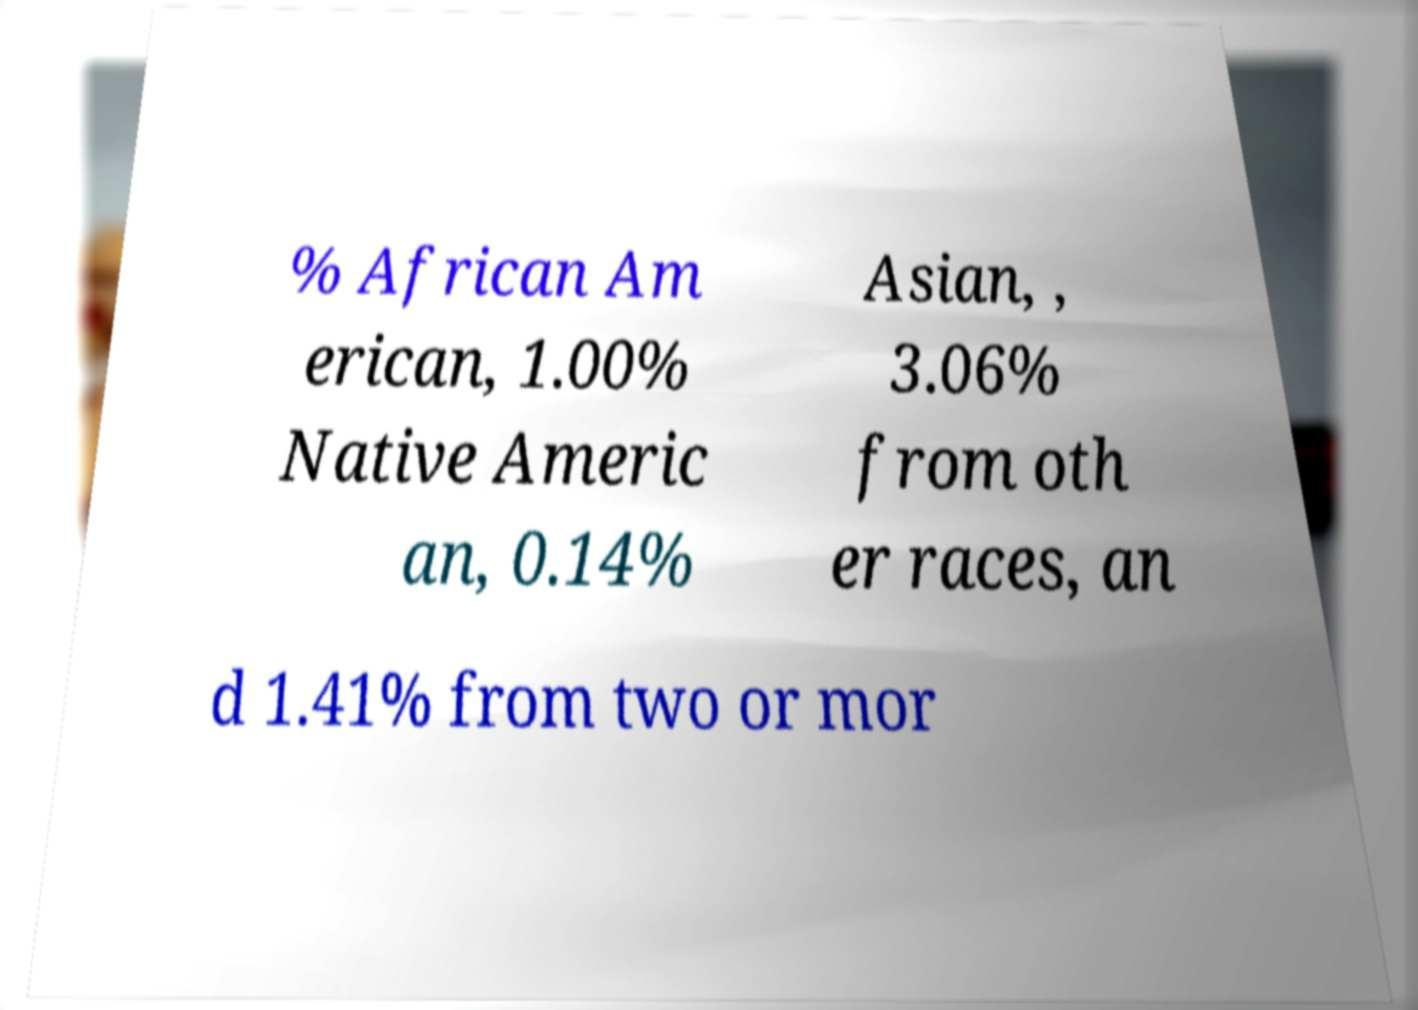Can you read and provide the text displayed in the image?This photo seems to have some interesting text. Can you extract and type it out for me? % African Am erican, 1.00% Native Americ an, 0.14% Asian, , 3.06% from oth er races, an d 1.41% from two or mor 